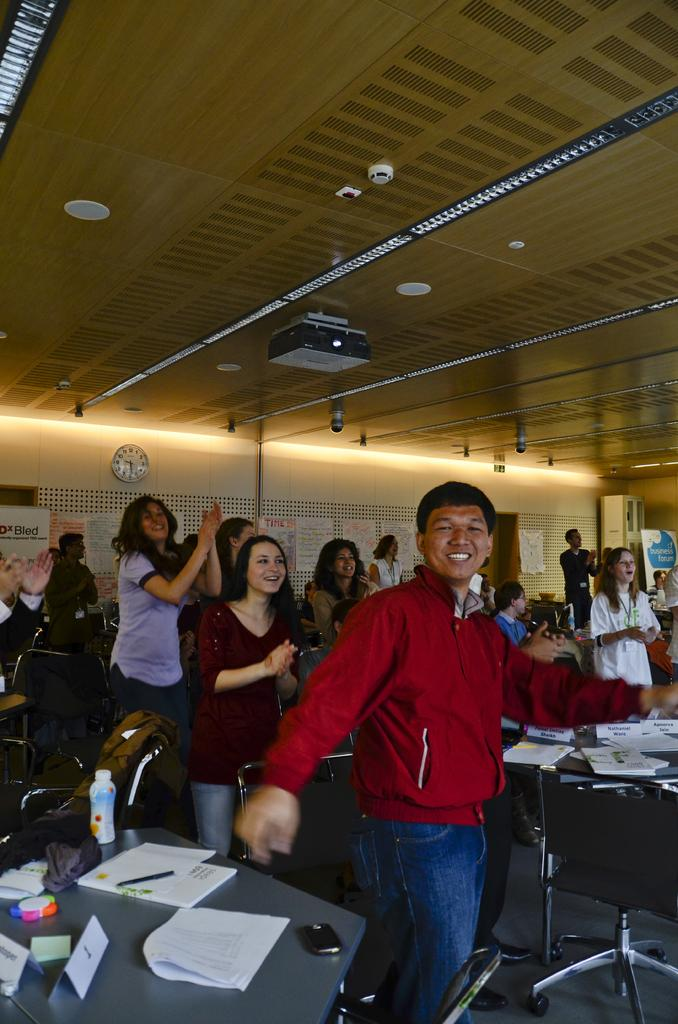What are the persons in the image doing? The persons in the image are applauding someone. What can be seen in the background of the image? There is a wall clock and a projector in the background of the image. What type of insurance policy is being discussed by the persons in the image? There is no indication in the image that the persons are discussing any insurance policies. What kind of seed is being planted by the persons in the image? There are no seeds or planting activities visible in the image. 